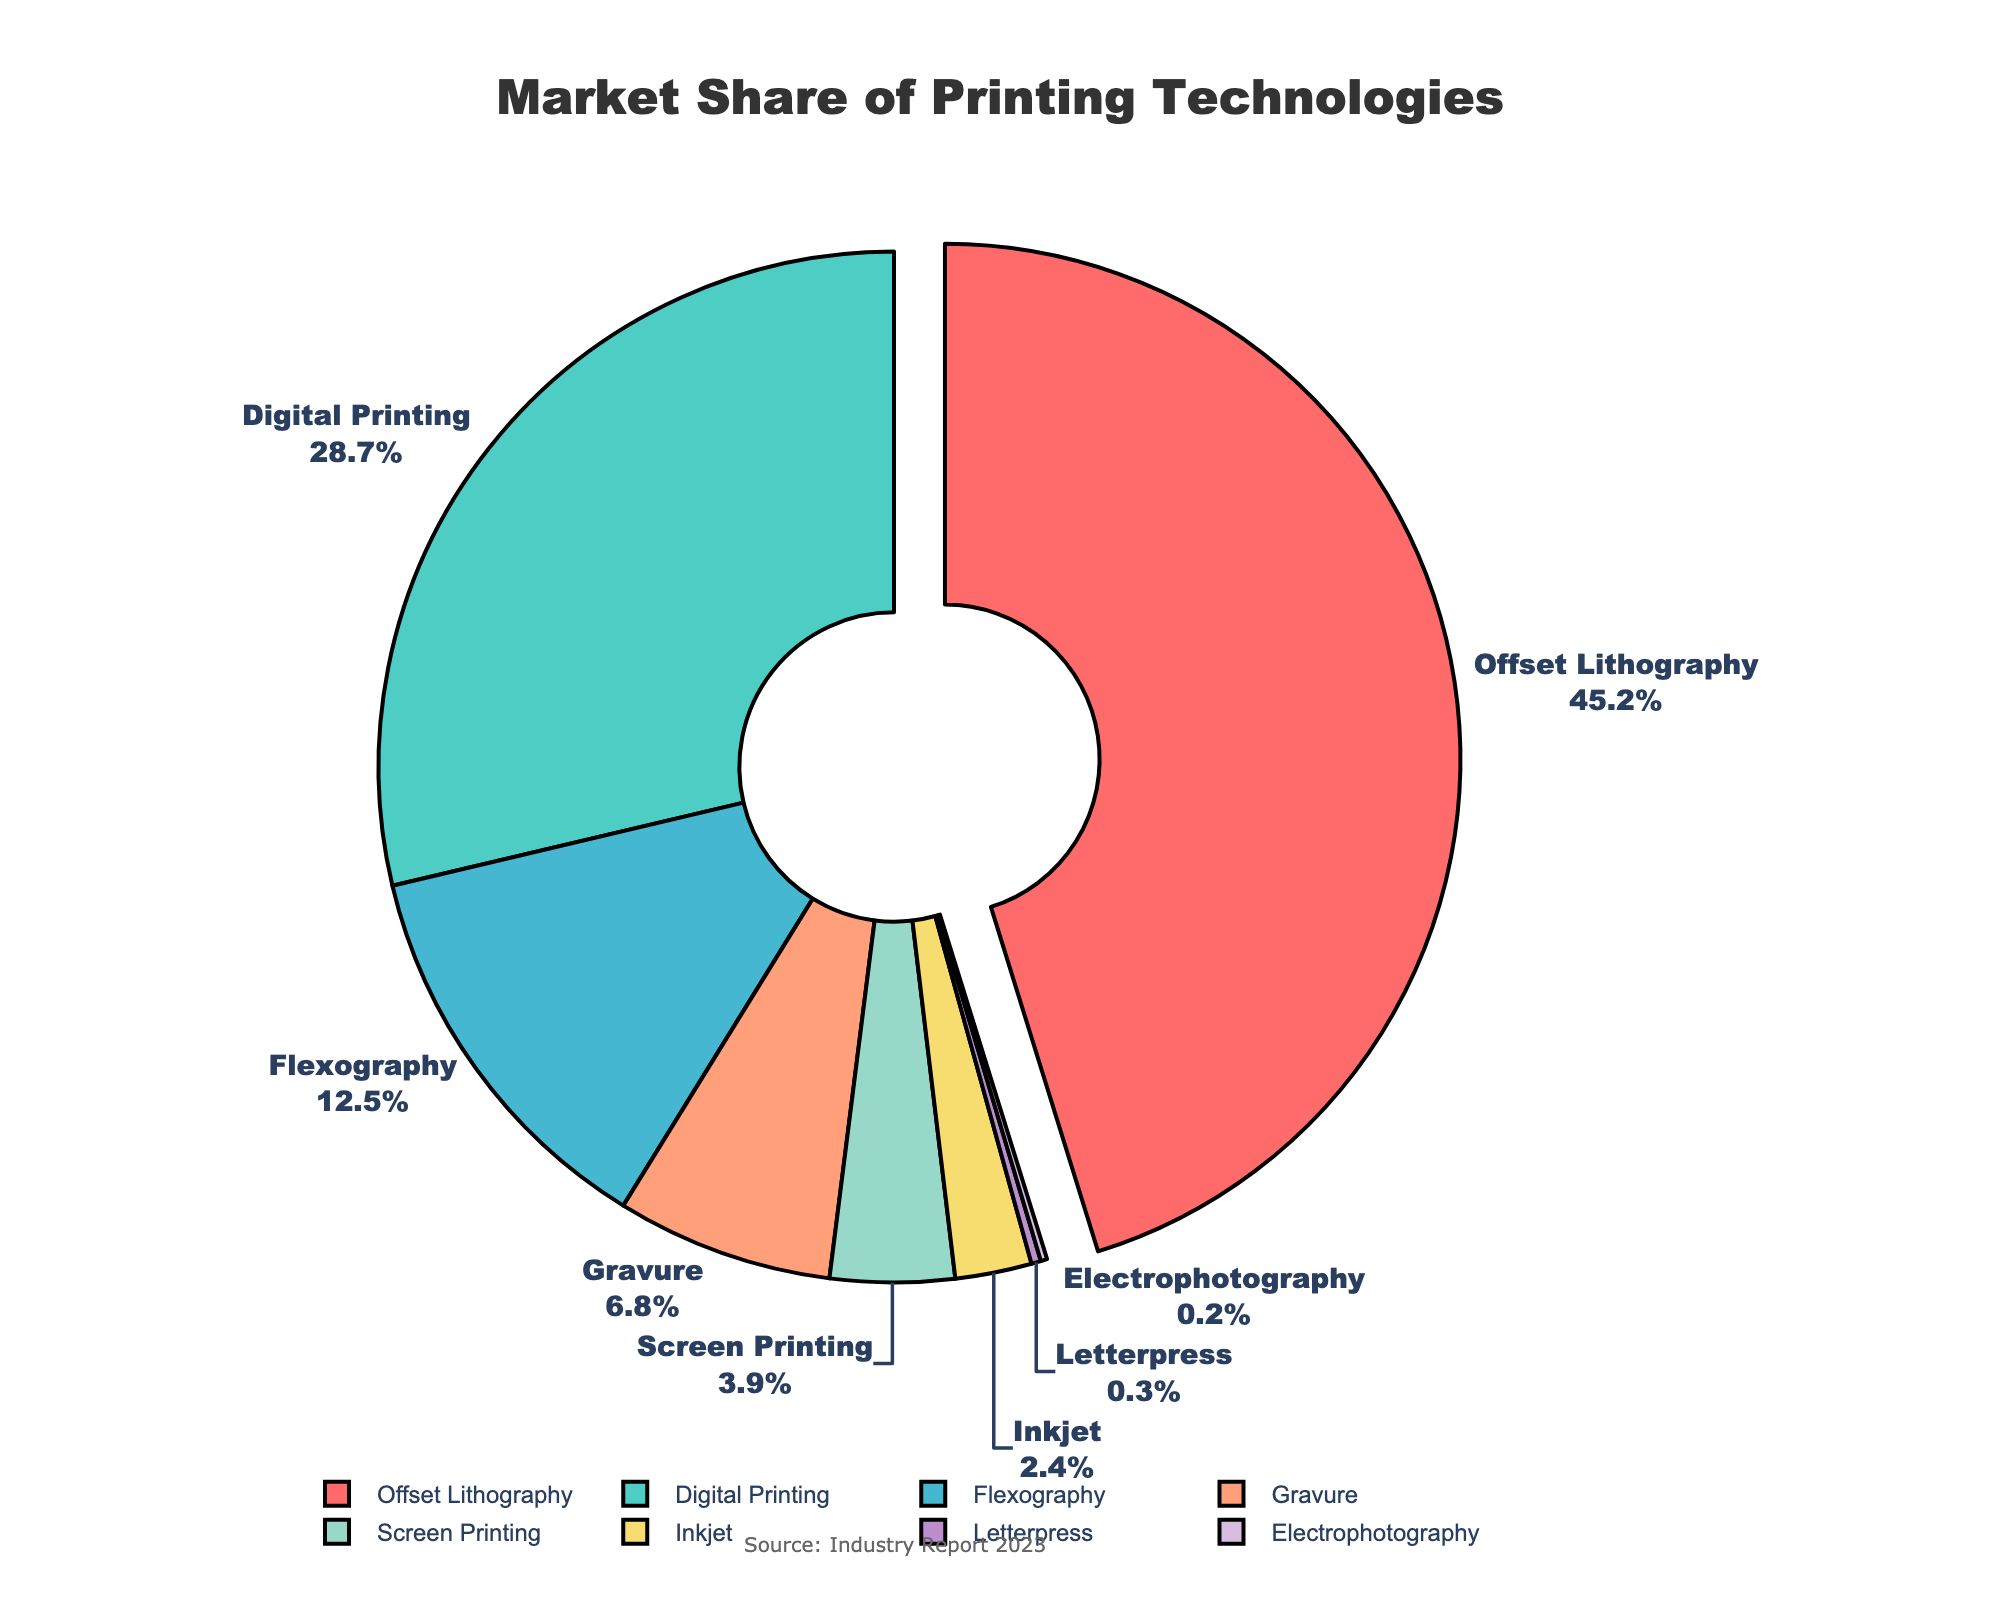What is the largest market share among the printing technologies? By visually inspecting the pie chart, we can see that the largest segment pulled out from the rest is Offset Lithography. Its market share is shown next to its label.
Answer: 45.2% Which printing technology has the smallest market share? By identifying the smallest segment in the pie chart, we find that Electrophotography is the smallest with the smallest percentage indicated next to its label.
Answer: 0.2% How much greater is the market share of Digital Printing compared to Flexography? Look at the percentages for Digital Printing and Flexography and subtract the smaller from the larger. Digital Printing: 28.7%, Flexography: 12.5%, so 28.7% - 12.5% = 16.2%.
Answer: 16.2% What is the combined market share of Gravure and Inkjet? Locate the market shares for Gravure and Inkjet and add them together. Gravure: 6.8%, Inkjet: 2.4%, so 6.8% + 2.4% = 9.2%.
Answer: 9.2% How much less is the market share of Screen Printing compared to Offset Lithography? Identify the market shares for Screen Printing and Offset Lithography and subtract Screen Printing's share from Offset Lithography's share. Offset Lithography: 45.2%, Screen Printing: 3.9%, so 45.2% - 3.9% = 41.3%.
Answer: 41.3% What percentage of the total market is accounted for by the top three technologies? Sum the market shares of the top three largest segments. Offset Lithography: 45.2%, Digital Printing: 28.7%, Flexography: 12.5%, so 45.2% + 28.7% + 12.5% = 86.4%.
Answer: 86.4% What is the visual cue used to highlight the largest market share? Observing the chart, we see that the largest segment, Offset Lithography, is separated or pulled out from the rest of the pie, drawing attention to it.
Answer: Pull-out segment What color is used for Digital Printing in the pie chart? By visually identifying the color of the segment labeled as Digital Printing, it is seen to be a greenish color.
Answer: Green (4ECDC4) 